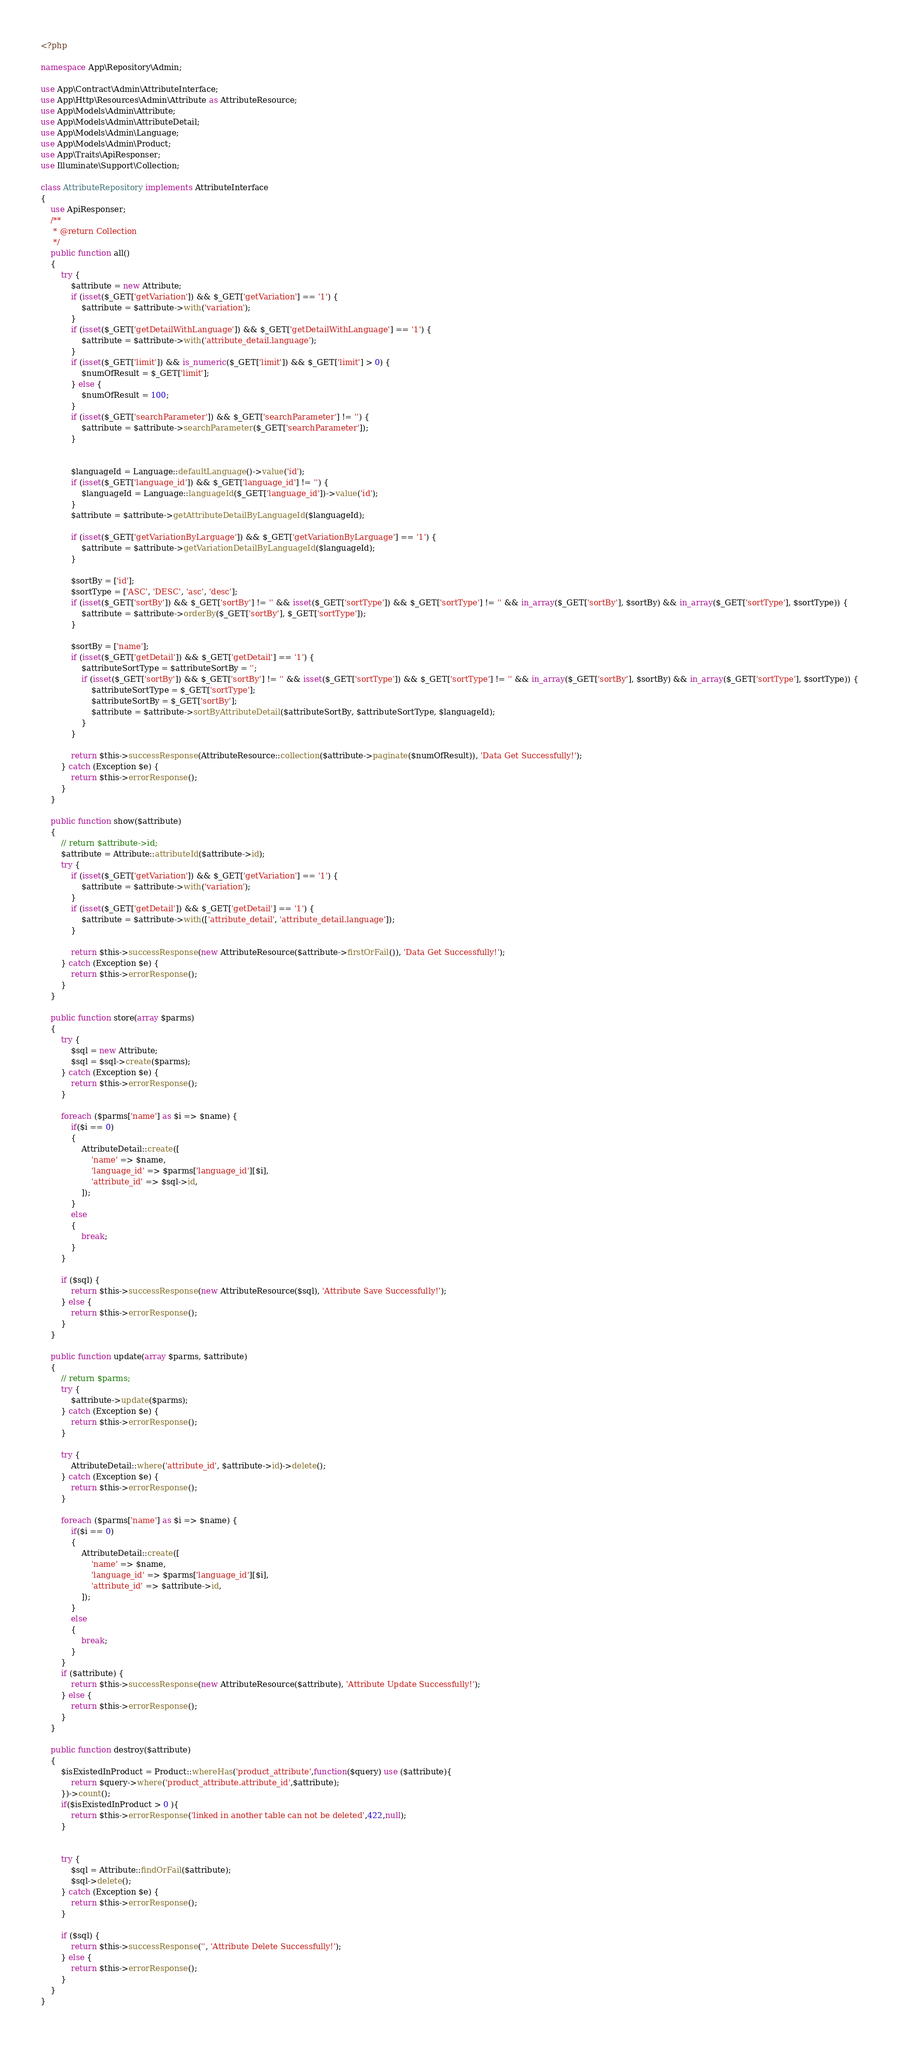Convert code to text. <code><loc_0><loc_0><loc_500><loc_500><_PHP_><?php

namespace App\Repository\Admin;

use App\Contract\Admin\AttributeInterface;
use App\Http\Resources\Admin\Attribute as AttributeResource;
use App\Models\Admin\Attribute;
use App\Models\Admin\AttributeDetail;
use App\Models\Admin\Language;
use App\Models\Admin\Product;
use App\Traits\ApiResponser;
use Illuminate\Support\Collection;

class AttributeRepository implements AttributeInterface
{
    use ApiResponser;
    /**
     * @return Collection
     */
    public function all()
    {
        try {
            $attribute = new Attribute;
            if (isset($_GET['getVariation']) && $_GET['getVariation'] == '1') {
                $attribute = $attribute->with('variation');
            }
            if (isset($_GET['getDetailWithLanguage']) && $_GET['getDetailWithLanguage'] == '1') {
                $attribute = $attribute->with('attribute_detail.language');
            }
            if (isset($_GET['limit']) && is_numeric($_GET['limit']) && $_GET['limit'] > 0) {
                $numOfResult = $_GET['limit'];
            } else {
                $numOfResult = 100;
            }
            if (isset($_GET['searchParameter']) && $_GET['searchParameter'] != '') {
                $attribute = $attribute->searchParameter($_GET['searchParameter']);
            }


            $languageId = Language::defaultLanguage()->value('id');
            if (isset($_GET['language_id']) && $_GET['language_id'] != '') {
                $languageId = Language::languageId($_GET['language_id'])->value('id');
            }
            $attribute = $attribute->getAttributeDetailByLanguageId($languageId);

            if (isset($_GET['getVariationByLarguage']) && $_GET['getVariationByLarguage'] == '1') {
                $attribute = $attribute->getVariationDetailByLanguageId($languageId);
            }

            $sortBy = ['id'];
            $sortType = ['ASC', 'DESC', 'asc', 'desc'];
            if (isset($_GET['sortBy']) && $_GET['sortBy'] != '' && isset($_GET['sortType']) && $_GET['sortType'] != '' && in_array($_GET['sortBy'], $sortBy) && in_array($_GET['sortType'], $sortType)) {
                $attribute = $attribute->orderBy($_GET['sortBy'], $_GET['sortType']);
            }

            $sortBy = ['name'];
            if (isset($_GET['getDetail']) && $_GET['getDetail'] == '1') {
                $attributeSortType = $attributeSortBy = '';
                if (isset($_GET['sortBy']) && $_GET['sortBy'] != '' && isset($_GET['sortType']) && $_GET['sortType'] != '' && in_array($_GET['sortBy'], $sortBy) && in_array($_GET['sortType'], $sortType)) {
                    $attributeSortType = $_GET['sortType'];
                    $attributeSortBy = $_GET['sortBy'];
                    $attribute = $attribute->sortByAttributeDetail($attributeSortBy, $attributeSortType, $languageId);
                }
            }

            return $this->successResponse(AttributeResource::collection($attribute->paginate($numOfResult)), 'Data Get Successfully!');
        } catch (Exception $e) {
            return $this->errorResponse();
        }
    }

    public function show($attribute)
    {
        // return $attribute->id;
        $attribute = Attribute::attributeId($attribute->id);
        try {
            if (isset($_GET['getVariation']) && $_GET['getVariation'] == '1') {
                $attribute = $attribute->with('variation');
            }
            if (isset($_GET['getDetail']) && $_GET['getDetail'] == '1') {
                $attribute = $attribute->with(['attribute_detail', 'attribute_detail.language']);
            }

            return $this->successResponse(new AttributeResource($attribute->firstOrFail()), 'Data Get Successfully!');
        } catch (Exception $e) {
            return $this->errorResponse();
        }
    }

    public function store(array $parms)
    {
        try {
            $sql = new Attribute;
            $sql = $sql->create($parms);
        } catch (Exception $e) {
            return $this->errorResponse();
        }

        foreach ($parms['name'] as $i => $name) {
            if($i == 0)
            {
                AttributeDetail::create([
                    'name' => $name,
                    'language_id' => $parms['language_id'][$i],
                    'attribute_id' => $sql->id,
                ]);
            }
            else
            {
                break;
            }
        }

        if ($sql) {
            return $this->successResponse(new AttributeResource($sql), 'Attribute Save Successfully!');
        } else {
            return $this->errorResponse();
        }
    }

    public function update(array $parms, $attribute)
    {
        // return $parms;
        try {
            $attribute->update($parms);
        } catch (Exception $e) {
            return $this->errorResponse();
        }

        try {
            AttributeDetail::where('attribute_id', $attribute->id)->delete();
        } catch (Exception $e) {
            return $this->errorResponse();
        }

        foreach ($parms['name'] as $i => $name) {
            if($i == 0)
            {
                AttributeDetail::create([
                    'name' => $name,
                    'language_id' => $parms['language_id'][$i],
                    'attribute_id' => $attribute->id,
                ]);
            }
            else
            {
                break;
            }
        }
        if ($attribute) {
            return $this->successResponse(new AttributeResource($attribute), 'Attribute Update Successfully!');
        } else {
            return $this->errorResponse();
        }
    }

    public function destroy($attribute)
    {
        $isExistedInProduct = Product::whereHas('product_attribute',function($query) use ($attribute){
            return $query->where('product_attribute.attribute_id',$attribute);
        })->count();
        if($isExistedInProduct > 0 ){
            return $this->errorResponse('linked in another table can not be deleted',422,null);
        }


        try {
            $sql = Attribute::findOrFail($attribute);
            $sql->delete();
        } catch (Exception $e) {
            return $this->errorResponse();
        }

        if ($sql) {
            return $this->successResponse('', 'Attribute Delete Successfully!');
        } else {
            return $this->errorResponse();
        }
    }
}
</code> 